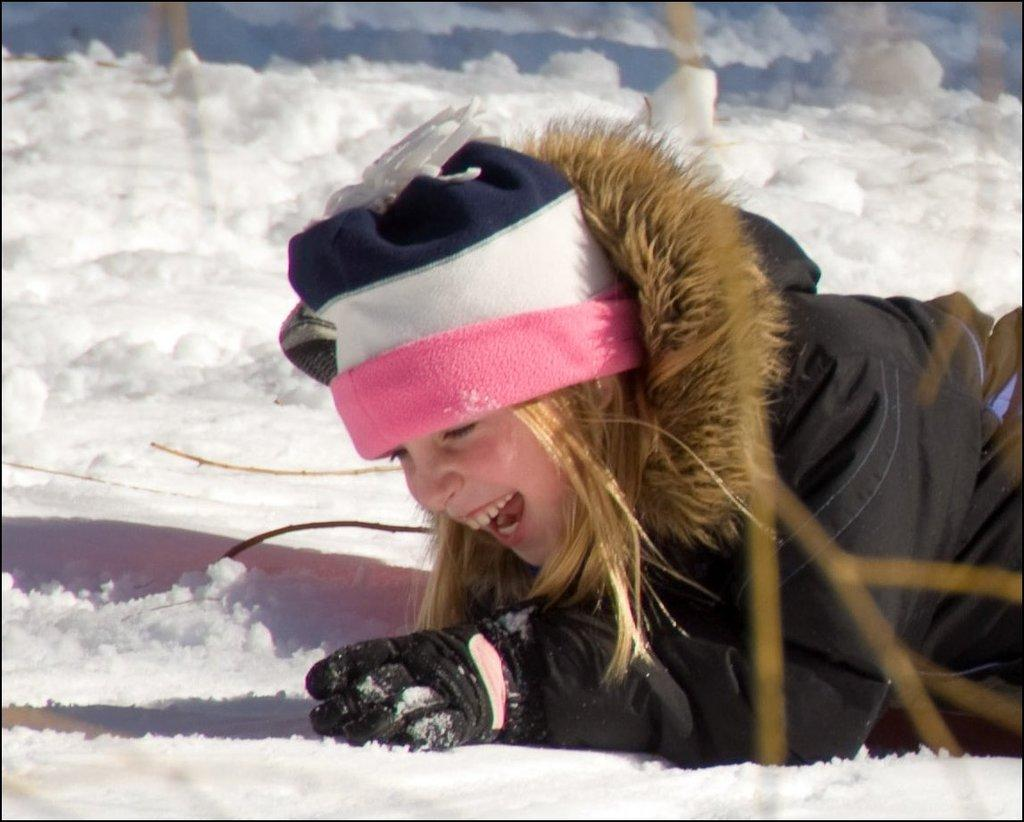Who is the main subject in the image? There is a girl in the image. What is the girl doing in the image? The girl is lying on the ground. What is the girl wearing in the image? The girl is wearing a black jacket and a cap. What is the setting of the image? There is snow at the bottom of the image. What type of animal can be seen playing with a drum in the image? There is no animal or drum present in the image. 